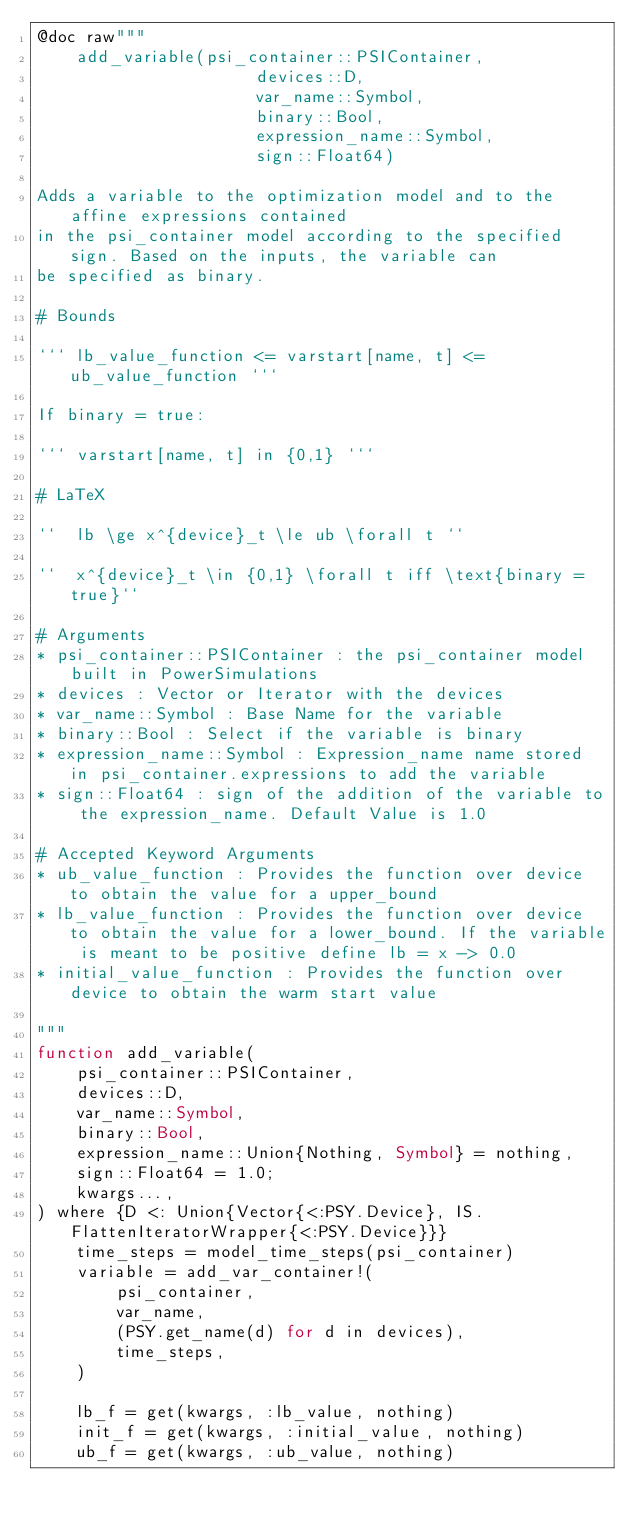<code> <loc_0><loc_0><loc_500><loc_500><_Julia_>@doc raw"""
    add_variable(psi_container::PSIContainer,
                      devices::D,
                      var_name::Symbol,
                      binary::Bool,
                      expression_name::Symbol,
                      sign::Float64)

Adds a variable to the optimization model and to the affine expressions contained
in the psi_container model according to the specified sign. Based on the inputs, the variable can
be specified as binary.

# Bounds

``` lb_value_function <= varstart[name, t] <= ub_value_function ```

If binary = true:

``` varstart[name, t] in {0,1} ```

# LaTeX

``  lb \ge x^{device}_t \le ub \forall t ``

``  x^{device}_t \in {0,1} \forall t iff \text{binary = true}``

# Arguments
* psi_container::PSIContainer : the psi_container model built in PowerSimulations
* devices : Vector or Iterator with the devices
* var_name::Symbol : Base Name for the variable
* binary::Bool : Select if the variable is binary
* expression_name::Symbol : Expression_name name stored in psi_container.expressions to add the variable
* sign::Float64 : sign of the addition of the variable to the expression_name. Default Value is 1.0

# Accepted Keyword Arguments
* ub_value_function : Provides the function over device to obtain the value for a upper_bound
* lb_value_function : Provides the function over device to obtain the value for a lower_bound. If the variable is meant to be positive define lb = x -> 0.0
* initial_value_function : Provides the function over device to obtain the warm start value

"""
function add_variable(
    psi_container::PSIContainer,
    devices::D,
    var_name::Symbol,
    binary::Bool,
    expression_name::Union{Nothing, Symbol} = nothing,
    sign::Float64 = 1.0;
    kwargs...,
) where {D <: Union{Vector{<:PSY.Device}, IS.FlattenIteratorWrapper{<:PSY.Device}}}
    time_steps = model_time_steps(psi_container)
    variable = add_var_container!(
        psi_container,
        var_name,
        (PSY.get_name(d) for d in devices),
        time_steps,
    )

    lb_f = get(kwargs, :lb_value, nothing)
    init_f = get(kwargs, :initial_value, nothing)
    ub_f = get(kwargs, :ub_value, nothing)
</code> 